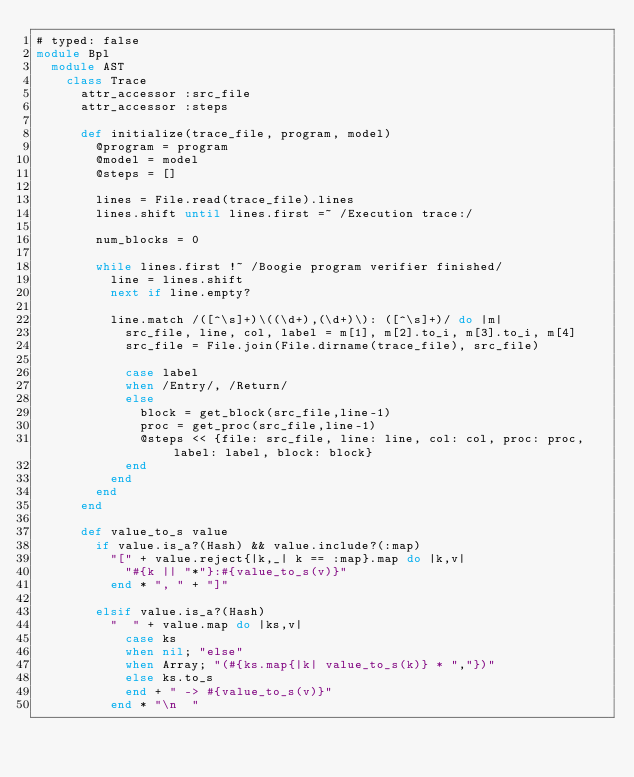<code> <loc_0><loc_0><loc_500><loc_500><_Ruby_># typed: false
module Bpl
  module AST
    class Trace
      attr_accessor :src_file
      attr_accessor :steps
      
      def initialize(trace_file, program, model)
        @program = program
        @model = model
        @steps = []

        lines = File.read(trace_file).lines
        lines.shift until lines.first =~ /Execution trace:/

        num_blocks = 0

        while lines.first !~ /Boogie program verifier finished/
          line = lines.shift
          next if line.empty?  
  
          line.match /([^\s]+)\((\d+),(\d+)\): ([^\s]+)/ do |m|
            src_file, line, col, label = m[1], m[2].to_i, m[3].to_i, m[4]
            src_file = File.join(File.dirname(trace_file), src_file)
    
            case label
            when /Entry/, /Return/
            else
              block = get_block(src_file,line-1)
              proc = get_proc(src_file,line-1)
              @steps << {file: src_file, line: line, col: col, proc: proc, label: label, block: block}
            end
          end
        end
      end

      def value_to_s value
        if value.is_a?(Hash) && value.include?(:map)
          "[" + value.reject{|k,_| k == :map}.map do |k,v|
            "#{k || "*"}:#{value_to_s(v)}"
          end * ", " + "]"

        elsif value.is_a?(Hash)
          "  " + value.map do |ks,v|
            case ks
            when nil; "else"
            when Array; "(#{ks.map{|k| value_to_s(k)} * ","})"
            else ks.to_s
            end + " -> #{value_to_s(v)}"
          end * "\n  "
</code> 